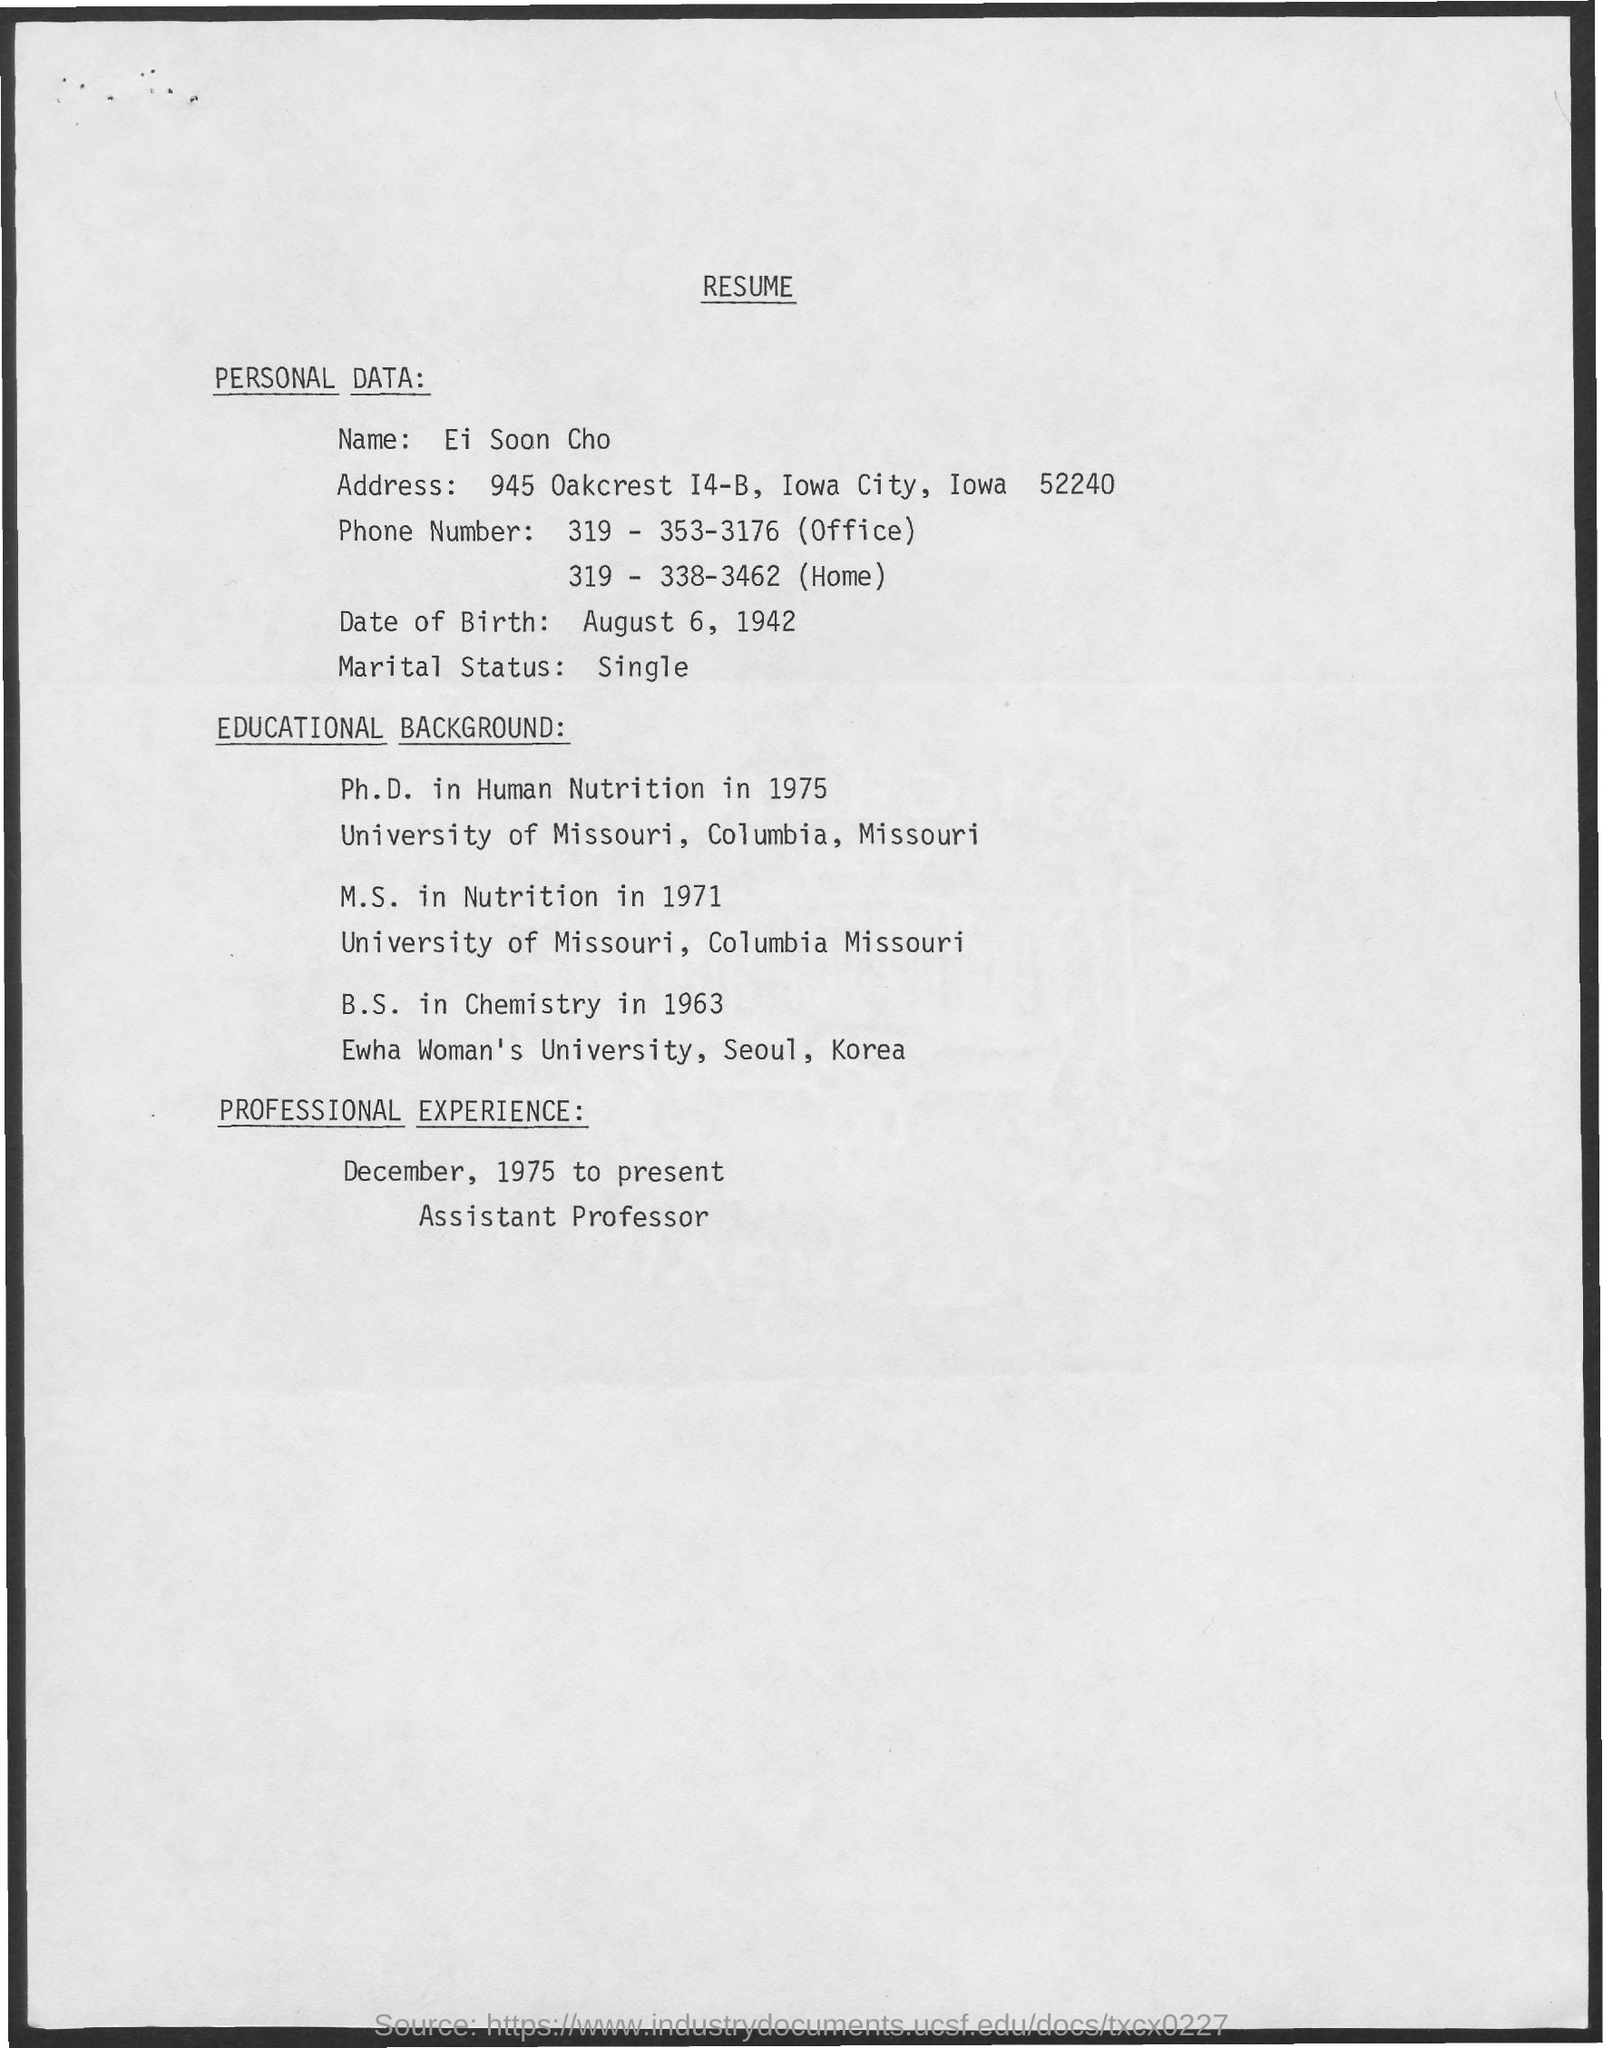Identify some key points in this picture. The name of the person to whom this resume belongs is Ei Soon Cho. 